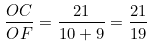<formula> <loc_0><loc_0><loc_500><loc_500>\frac { O C } { O F } = \frac { 2 1 } { 1 0 + 9 } = \frac { 2 1 } { 1 9 }</formula> 